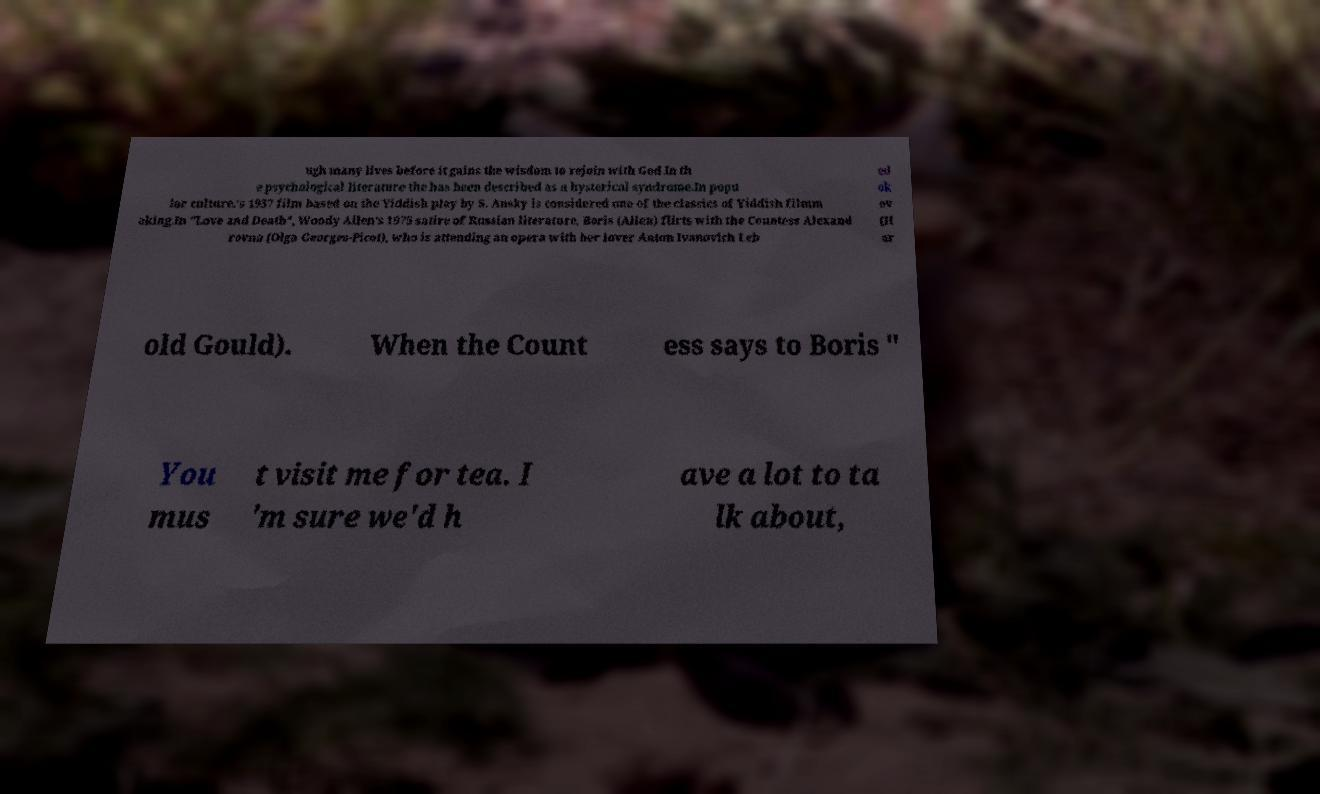Can you read and provide the text displayed in the image?This photo seems to have some interesting text. Can you extract and type it out for me? ugh many lives before it gains the wisdom to rejoin with God.In th e psychological literature the has been described as a hysterical syndrome.In popu lar culture.'s 1937 film based on the Yiddish play by S. Ansky is considered one of the classics of Yiddish filmm aking.In "Love and Death", Woody Allen's 1975 satire of Russian literature, Boris (Allen) flirts with the Countess Alexand rovna (Olga Georges-Picot), who is attending an opera with her lover Anton Ivanovich Leb ed ok ov (H ar old Gould). When the Count ess says to Boris " You mus t visit me for tea. I 'm sure we'd h ave a lot to ta lk about, 